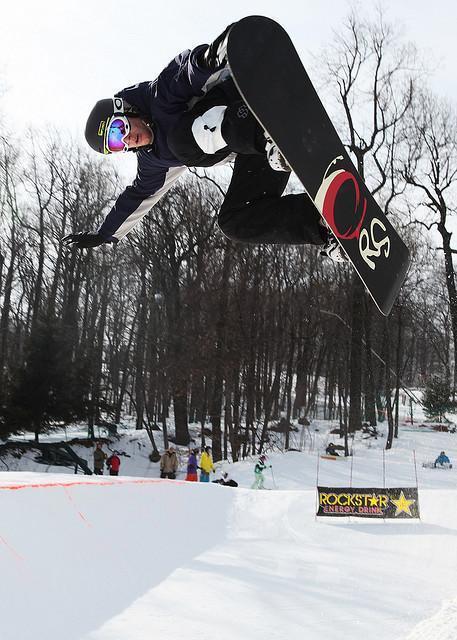How many birds are in the air flying?
Give a very brief answer. 0. 